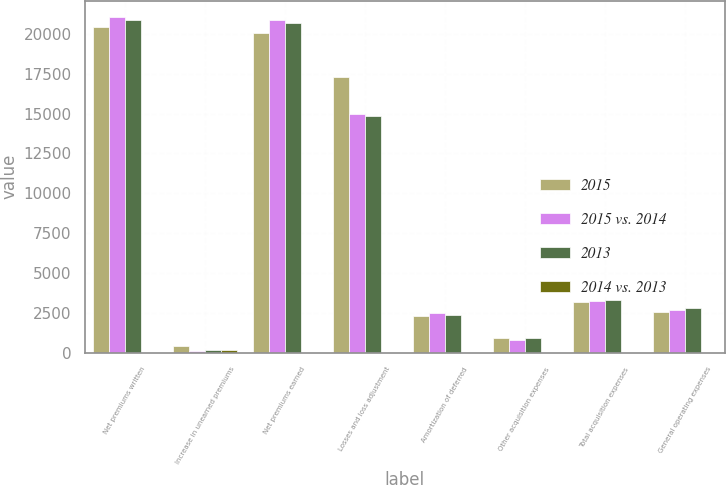Convert chart. <chart><loc_0><loc_0><loc_500><loc_500><stacked_bar_chart><ecel><fcel>Net premiums written<fcel>Increase in unearned premiums<fcel>Net premiums earned<fcel>Losses and loss adjustment<fcel>Amortization of deferred<fcel>Other acquisition expenses<fcel>Total acquisition expenses<fcel>General operating expenses<nl><fcel>2015<fcel>20436<fcel>407<fcel>20029<fcel>17274<fcel>2309<fcel>907<fcel>3216<fcel>2542<nl><fcel>2015 vs. 2014<fcel>21020<fcel>135<fcel>20885<fcel>14956<fcel>2486<fcel>796<fcel>3282<fcel>2697<nl><fcel>2013<fcel>20880<fcel>203<fcel>20677<fcel>14872<fcel>2394<fcel>937<fcel>3331<fcel>2810<nl><fcel>2014 vs. 2013<fcel>3<fcel>201<fcel>4<fcel>15<fcel>7<fcel>14<fcel>2<fcel>6<nl></chart> 